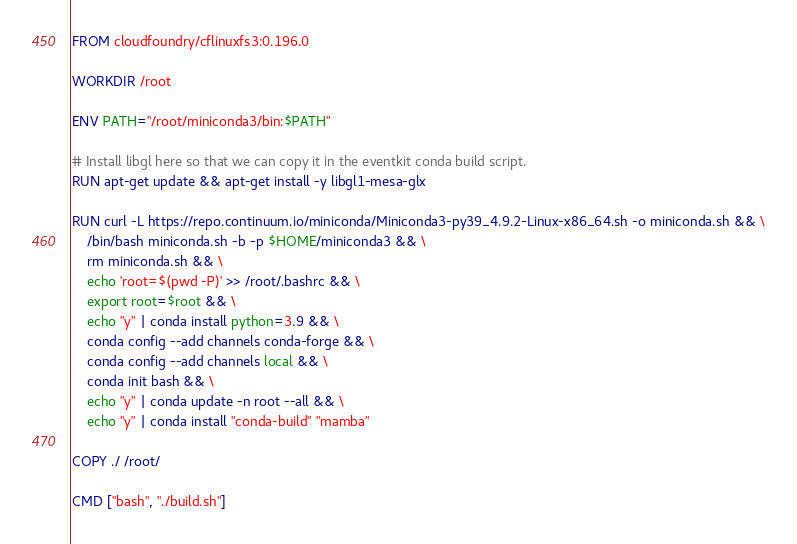<code> <loc_0><loc_0><loc_500><loc_500><_Dockerfile_>FROM cloudfoundry/cflinuxfs3:0.196.0

WORKDIR /root

ENV PATH="/root/miniconda3/bin:$PATH"

# Install libgl here so that we can copy it in the eventkit conda build script.
RUN apt-get update && apt-get install -y libgl1-mesa-glx

RUN curl -L https://repo.continuum.io/miniconda/Miniconda3-py39_4.9.2-Linux-x86_64.sh -o miniconda.sh && \
    /bin/bash miniconda.sh -b -p $HOME/miniconda3 && \
    rm miniconda.sh && \
    echo 'root=$(pwd -P)' >> /root/.bashrc && \
    export root=$root && \
    echo "y" | conda install python=3.9 && \
    conda config --add channels conda-forge && \
    conda config --add channels local && \
    conda init bash && \
    echo "y" | conda update -n root --all && \
    echo "y" | conda install "conda-build" "mamba"

COPY ./ /root/

CMD ["bash", "./build.sh"]
</code> 